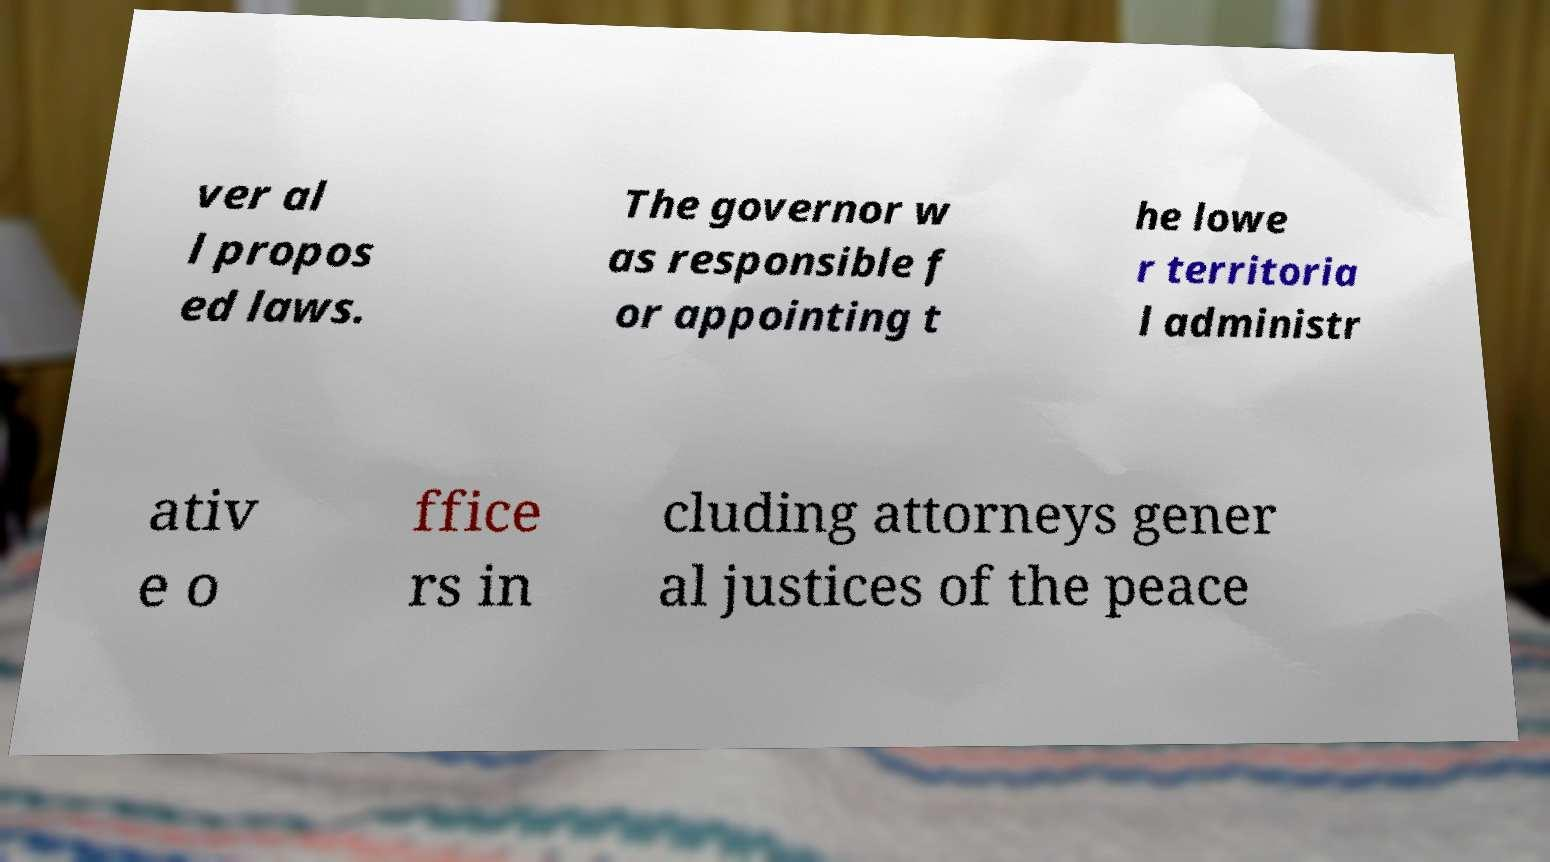There's text embedded in this image that I need extracted. Can you transcribe it verbatim? ver al l propos ed laws. The governor w as responsible f or appointing t he lowe r territoria l administr ativ e o ffice rs in cluding attorneys gener al justices of the peace 